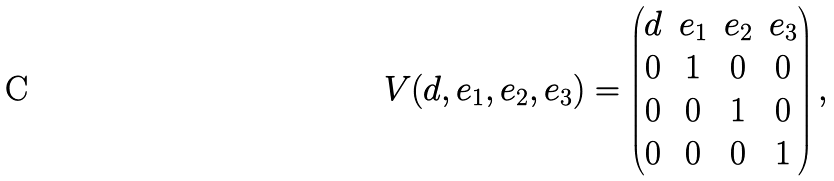<formula> <loc_0><loc_0><loc_500><loc_500>V ( d , e _ { 1 } , e _ { 2 } , e _ { 3 } ) = \begin{pmatrix} d & e _ { 1 } & e _ { 2 } & e _ { 3 } \\ 0 & 1 & 0 & 0 \\ 0 & 0 & 1 & 0 \\ 0 & 0 & 0 & 1 \end{pmatrix} ,</formula> 